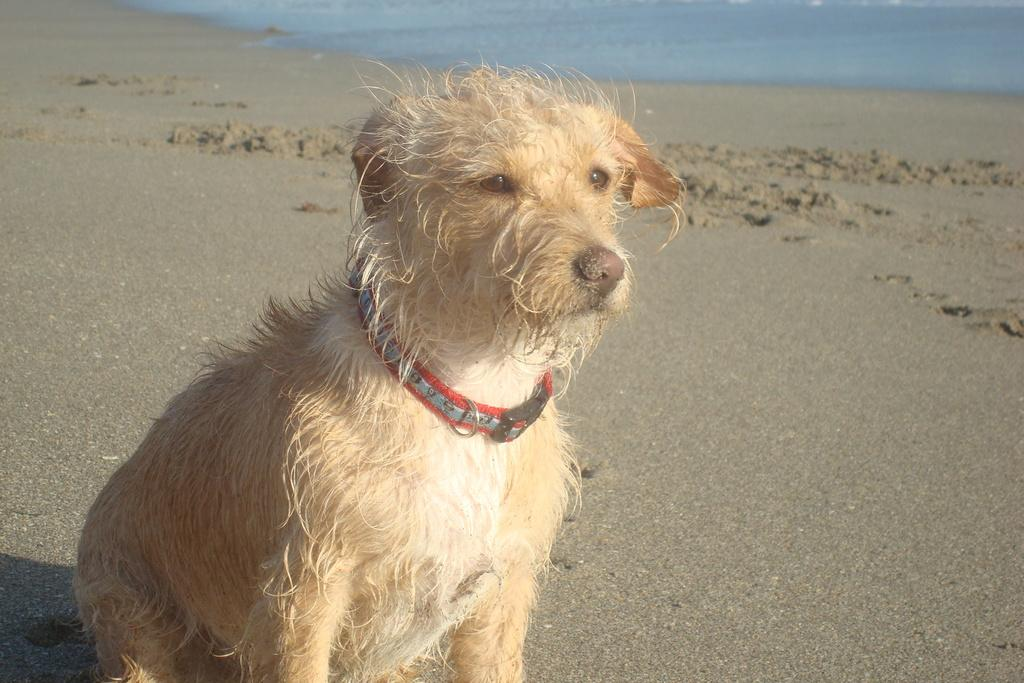What animal can be seen in the image? There is a dog in the image. Where is the dog located in the image? The dog is sitting on the seashore. What can be seen in the background of the image? There is a sea visible in the background of the image. What type of farm can be seen in the background of the image? There is no farm present in the image; it features a dog sitting on the seashore with a sea visible in the background. 